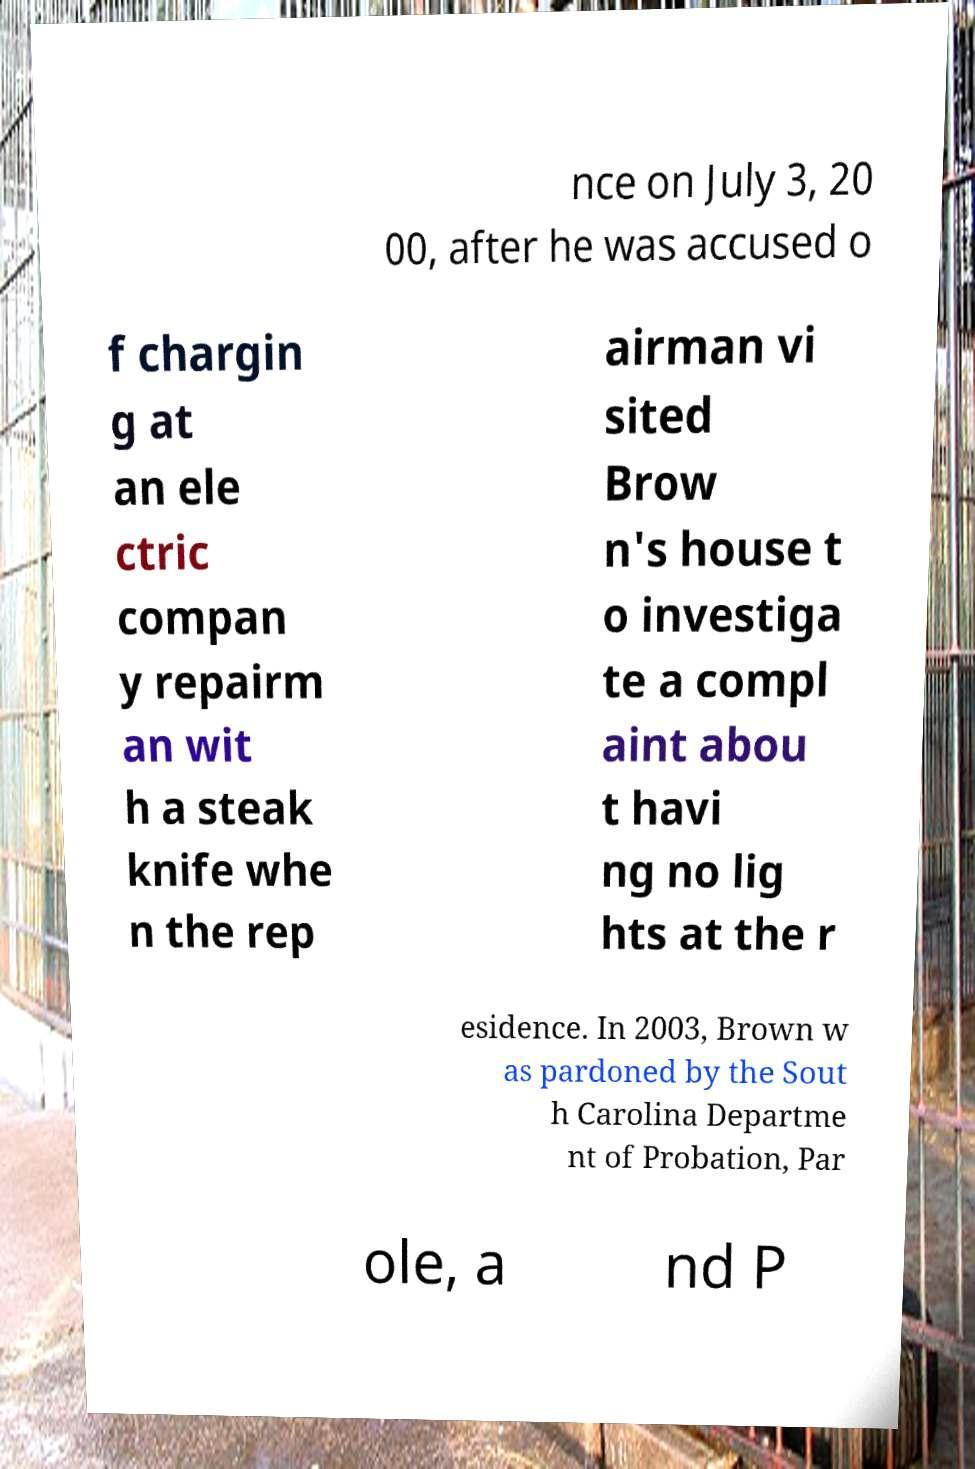I need the written content from this picture converted into text. Can you do that? nce on July 3, 20 00, after he was accused o f chargin g at an ele ctric compan y repairm an wit h a steak knife whe n the rep airman vi sited Brow n's house t o investiga te a compl aint abou t havi ng no lig hts at the r esidence. In 2003, Brown w as pardoned by the Sout h Carolina Departme nt of Probation, Par ole, a nd P 